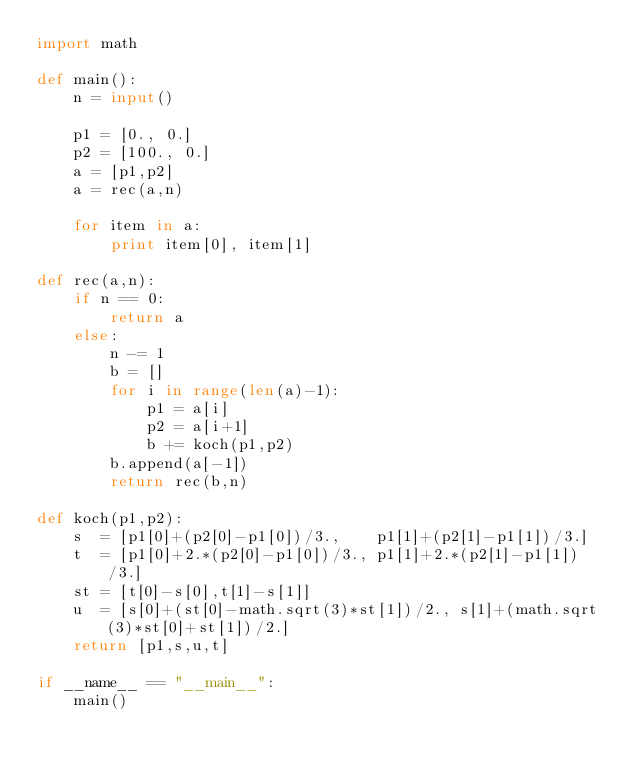<code> <loc_0><loc_0><loc_500><loc_500><_Python_>import math

def main():
    n = input()

    p1 = [0., 0.]
    p2 = [100., 0.]
    a = [p1,p2]
    a = rec(a,n)

    for item in a:
        print item[0], item[1]
    
def rec(a,n):
    if n == 0:
        return a
    else:
        n -= 1
        b = []
        for i in range(len(a)-1):
            p1 = a[i]
            p2 = a[i+1]
            b += koch(p1,p2)
        b.append(a[-1])
        return rec(b,n)

def koch(p1,p2):
    s  = [p1[0]+(p2[0]-p1[0])/3.,    p1[1]+(p2[1]-p1[1])/3.]
    t  = [p1[0]+2.*(p2[0]-p1[0])/3., p1[1]+2.*(p2[1]-p1[1])/3.]
    st = [t[0]-s[0],t[1]-s[1]]
    u  = [s[0]+(st[0]-math.sqrt(3)*st[1])/2., s[1]+(math.sqrt(3)*st[0]+st[1])/2.]
    return [p1,s,u,t]
    
if __name__ == "__main__":
    main()</code> 